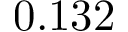Convert formula to latex. <formula><loc_0><loc_0><loc_500><loc_500>0 . 1 3 2</formula> 